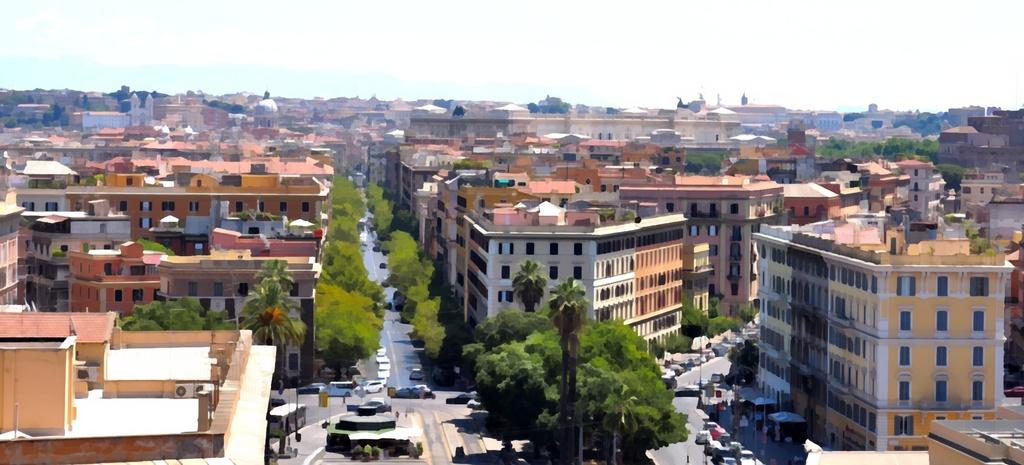What type of location is depicted in the image? The image depicts a city. What can be seen in the sky in the image? There is a sky with clouds in the image. What type of structures are present in the image? There are buildings in the image. What type of vegetation is present in the image? Trees are present in the image. What type of appliances are visible in the image? Air conditioners are visible in the image. What type of infrastructure is present in the image? Pipelines are present in the image. What type of vertical structures are visible in the image? Poles are visible in the image. What type of commercial displays are present in the image? Advertisement boards are present in the image. What type of transportation is visible on the road in the image? Motor vehicles are visible on the road in the image. What color is the tiger walking on the road in the image? There is no tiger present in the image; it depicts a city with motor vehicles on the road. 